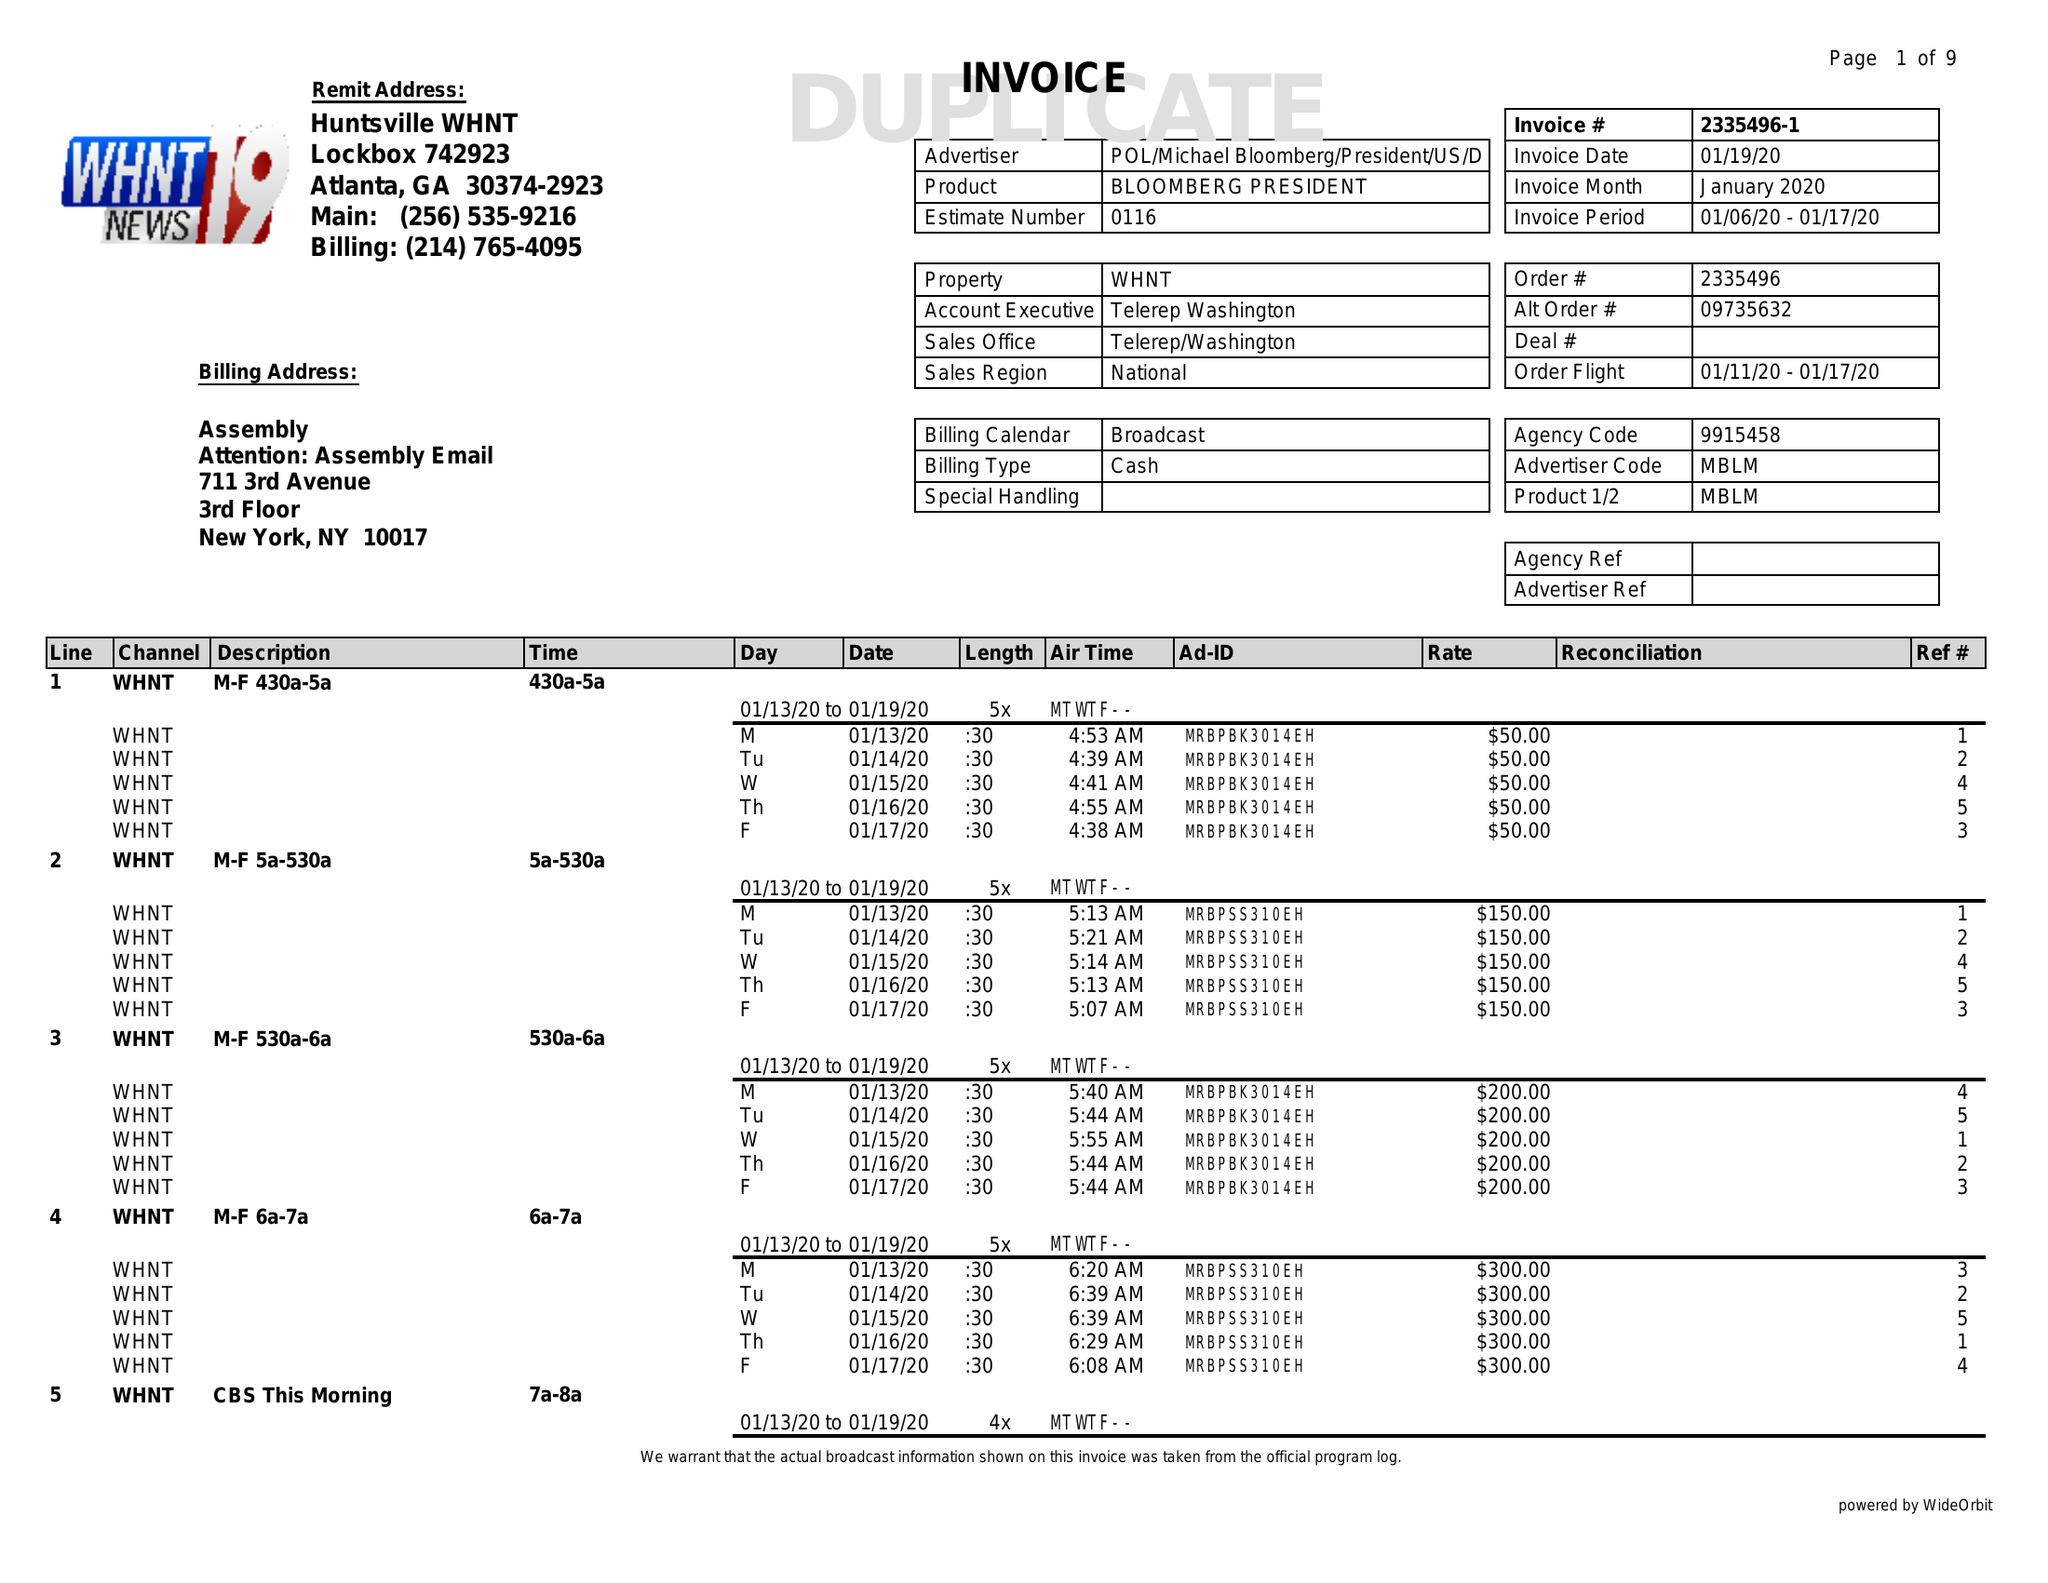What is the value for the contract_num?
Answer the question using a single word or phrase. 2335496 